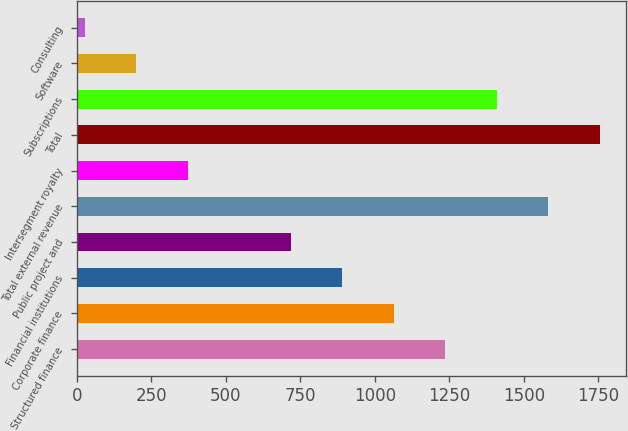Convert chart to OTSL. <chart><loc_0><loc_0><loc_500><loc_500><bar_chart><fcel>Structured finance<fcel>Corporate finance<fcel>Financial institutions<fcel>Public project and<fcel>Total external revenue<fcel>Intersegment royalty<fcel>Total<fcel>Subscriptions<fcel>Software<fcel>Consulting<nl><fcel>1236.46<fcel>1063.48<fcel>890.5<fcel>717.52<fcel>1582.42<fcel>371.56<fcel>1755.4<fcel>1409.44<fcel>198.58<fcel>25.6<nl></chart> 